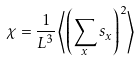<formula> <loc_0><loc_0><loc_500><loc_500>\chi = \frac { 1 } { L ^ { 3 } } \left \langle \left ( \sum _ { x } s _ { x } \right ) ^ { 2 } \right \rangle</formula> 